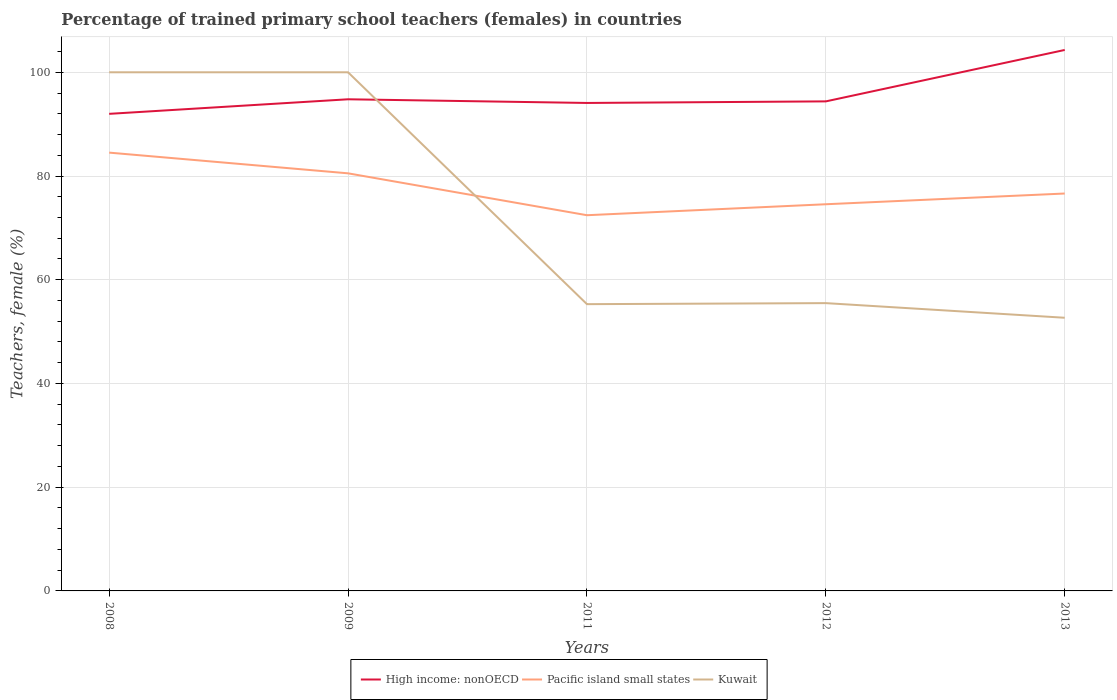How many different coloured lines are there?
Your answer should be very brief. 3. Does the line corresponding to Pacific island small states intersect with the line corresponding to Kuwait?
Give a very brief answer. Yes. Is the number of lines equal to the number of legend labels?
Keep it short and to the point. Yes. Across all years, what is the maximum percentage of trained primary school teachers (females) in Kuwait?
Keep it short and to the point. 52.67. In which year was the percentage of trained primary school teachers (females) in High income: nonOECD maximum?
Provide a short and direct response. 2008. What is the total percentage of trained primary school teachers (females) in Kuwait in the graph?
Make the answer very short. 44.51. What is the difference between the highest and the second highest percentage of trained primary school teachers (females) in High income: nonOECD?
Make the answer very short. 12.32. What is the difference between the highest and the lowest percentage of trained primary school teachers (females) in Kuwait?
Offer a very short reply. 2. How many lines are there?
Your response must be concise. 3. How many years are there in the graph?
Offer a terse response. 5. What is the difference between two consecutive major ticks on the Y-axis?
Offer a very short reply. 20. Are the values on the major ticks of Y-axis written in scientific E-notation?
Make the answer very short. No. Does the graph contain any zero values?
Give a very brief answer. No. Where does the legend appear in the graph?
Your answer should be very brief. Bottom center. How many legend labels are there?
Keep it short and to the point. 3. What is the title of the graph?
Your answer should be compact. Percentage of trained primary school teachers (females) in countries. What is the label or title of the X-axis?
Give a very brief answer. Years. What is the label or title of the Y-axis?
Offer a very short reply. Teachers, female (%). What is the Teachers, female (%) of High income: nonOECD in 2008?
Offer a very short reply. 91.99. What is the Teachers, female (%) in Pacific island small states in 2008?
Give a very brief answer. 84.51. What is the Teachers, female (%) of Kuwait in 2008?
Give a very brief answer. 100. What is the Teachers, female (%) in High income: nonOECD in 2009?
Your response must be concise. 94.79. What is the Teachers, female (%) in Pacific island small states in 2009?
Offer a terse response. 80.52. What is the Teachers, female (%) in Kuwait in 2009?
Your answer should be compact. 100. What is the Teachers, female (%) of High income: nonOECD in 2011?
Provide a short and direct response. 94.08. What is the Teachers, female (%) in Pacific island small states in 2011?
Your answer should be compact. 72.44. What is the Teachers, female (%) of Kuwait in 2011?
Give a very brief answer. 55.29. What is the Teachers, female (%) in High income: nonOECD in 2012?
Provide a short and direct response. 94.39. What is the Teachers, female (%) in Pacific island small states in 2012?
Make the answer very short. 74.55. What is the Teachers, female (%) of Kuwait in 2012?
Give a very brief answer. 55.49. What is the Teachers, female (%) in High income: nonOECD in 2013?
Provide a succinct answer. 104.3. What is the Teachers, female (%) in Pacific island small states in 2013?
Offer a very short reply. 76.62. What is the Teachers, female (%) of Kuwait in 2013?
Provide a short and direct response. 52.67. Across all years, what is the maximum Teachers, female (%) in High income: nonOECD?
Your answer should be compact. 104.3. Across all years, what is the maximum Teachers, female (%) of Pacific island small states?
Offer a very short reply. 84.51. Across all years, what is the maximum Teachers, female (%) of Kuwait?
Ensure brevity in your answer.  100. Across all years, what is the minimum Teachers, female (%) in High income: nonOECD?
Your answer should be very brief. 91.99. Across all years, what is the minimum Teachers, female (%) in Pacific island small states?
Your answer should be compact. 72.44. Across all years, what is the minimum Teachers, female (%) in Kuwait?
Your answer should be very brief. 52.67. What is the total Teachers, female (%) in High income: nonOECD in the graph?
Provide a succinct answer. 479.55. What is the total Teachers, female (%) of Pacific island small states in the graph?
Keep it short and to the point. 388.64. What is the total Teachers, female (%) in Kuwait in the graph?
Your answer should be compact. 363.45. What is the difference between the Teachers, female (%) in High income: nonOECD in 2008 and that in 2009?
Your response must be concise. -2.81. What is the difference between the Teachers, female (%) of Pacific island small states in 2008 and that in 2009?
Your answer should be very brief. 3.99. What is the difference between the Teachers, female (%) in Kuwait in 2008 and that in 2009?
Give a very brief answer. 0. What is the difference between the Teachers, female (%) of High income: nonOECD in 2008 and that in 2011?
Ensure brevity in your answer.  -2.1. What is the difference between the Teachers, female (%) in Pacific island small states in 2008 and that in 2011?
Your response must be concise. 12.07. What is the difference between the Teachers, female (%) in Kuwait in 2008 and that in 2011?
Keep it short and to the point. 44.71. What is the difference between the Teachers, female (%) of High income: nonOECD in 2008 and that in 2012?
Offer a very short reply. -2.4. What is the difference between the Teachers, female (%) of Pacific island small states in 2008 and that in 2012?
Your answer should be compact. 9.95. What is the difference between the Teachers, female (%) in Kuwait in 2008 and that in 2012?
Provide a short and direct response. 44.51. What is the difference between the Teachers, female (%) of High income: nonOECD in 2008 and that in 2013?
Offer a very short reply. -12.32. What is the difference between the Teachers, female (%) of Pacific island small states in 2008 and that in 2013?
Offer a terse response. 7.88. What is the difference between the Teachers, female (%) in Kuwait in 2008 and that in 2013?
Offer a very short reply. 47.33. What is the difference between the Teachers, female (%) in High income: nonOECD in 2009 and that in 2011?
Your answer should be compact. 0.71. What is the difference between the Teachers, female (%) of Pacific island small states in 2009 and that in 2011?
Give a very brief answer. 8.08. What is the difference between the Teachers, female (%) of Kuwait in 2009 and that in 2011?
Provide a short and direct response. 44.71. What is the difference between the Teachers, female (%) in High income: nonOECD in 2009 and that in 2012?
Give a very brief answer. 0.41. What is the difference between the Teachers, female (%) of Pacific island small states in 2009 and that in 2012?
Give a very brief answer. 5.96. What is the difference between the Teachers, female (%) of Kuwait in 2009 and that in 2012?
Your answer should be very brief. 44.51. What is the difference between the Teachers, female (%) of High income: nonOECD in 2009 and that in 2013?
Make the answer very short. -9.51. What is the difference between the Teachers, female (%) of Pacific island small states in 2009 and that in 2013?
Your answer should be compact. 3.89. What is the difference between the Teachers, female (%) of Kuwait in 2009 and that in 2013?
Your response must be concise. 47.33. What is the difference between the Teachers, female (%) in High income: nonOECD in 2011 and that in 2012?
Your answer should be very brief. -0.3. What is the difference between the Teachers, female (%) of Pacific island small states in 2011 and that in 2012?
Ensure brevity in your answer.  -2.12. What is the difference between the Teachers, female (%) in Kuwait in 2011 and that in 2012?
Keep it short and to the point. -0.2. What is the difference between the Teachers, female (%) of High income: nonOECD in 2011 and that in 2013?
Offer a terse response. -10.22. What is the difference between the Teachers, female (%) of Pacific island small states in 2011 and that in 2013?
Provide a short and direct response. -4.18. What is the difference between the Teachers, female (%) of Kuwait in 2011 and that in 2013?
Offer a very short reply. 2.62. What is the difference between the Teachers, female (%) of High income: nonOECD in 2012 and that in 2013?
Ensure brevity in your answer.  -9.91. What is the difference between the Teachers, female (%) in Pacific island small states in 2012 and that in 2013?
Make the answer very short. -2.07. What is the difference between the Teachers, female (%) of Kuwait in 2012 and that in 2013?
Keep it short and to the point. 2.82. What is the difference between the Teachers, female (%) of High income: nonOECD in 2008 and the Teachers, female (%) of Pacific island small states in 2009?
Your answer should be compact. 11.47. What is the difference between the Teachers, female (%) of High income: nonOECD in 2008 and the Teachers, female (%) of Kuwait in 2009?
Keep it short and to the point. -8.01. What is the difference between the Teachers, female (%) in Pacific island small states in 2008 and the Teachers, female (%) in Kuwait in 2009?
Provide a succinct answer. -15.49. What is the difference between the Teachers, female (%) of High income: nonOECD in 2008 and the Teachers, female (%) of Pacific island small states in 2011?
Your response must be concise. 19.55. What is the difference between the Teachers, female (%) in High income: nonOECD in 2008 and the Teachers, female (%) in Kuwait in 2011?
Provide a short and direct response. 36.69. What is the difference between the Teachers, female (%) in Pacific island small states in 2008 and the Teachers, female (%) in Kuwait in 2011?
Your answer should be compact. 29.22. What is the difference between the Teachers, female (%) in High income: nonOECD in 2008 and the Teachers, female (%) in Pacific island small states in 2012?
Your answer should be compact. 17.43. What is the difference between the Teachers, female (%) of High income: nonOECD in 2008 and the Teachers, female (%) of Kuwait in 2012?
Your answer should be very brief. 36.5. What is the difference between the Teachers, female (%) of Pacific island small states in 2008 and the Teachers, female (%) of Kuwait in 2012?
Provide a short and direct response. 29.02. What is the difference between the Teachers, female (%) in High income: nonOECD in 2008 and the Teachers, female (%) in Pacific island small states in 2013?
Your answer should be very brief. 15.36. What is the difference between the Teachers, female (%) in High income: nonOECD in 2008 and the Teachers, female (%) in Kuwait in 2013?
Your answer should be very brief. 39.32. What is the difference between the Teachers, female (%) in Pacific island small states in 2008 and the Teachers, female (%) in Kuwait in 2013?
Your response must be concise. 31.84. What is the difference between the Teachers, female (%) in High income: nonOECD in 2009 and the Teachers, female (%) in Pacific island small states in 2011?
Provide a succinct answer. 22.36. What is the difference between the Teachers, female (%) of High income: nonOECD in 2009 and the Teachers, female (%) of Kuwait in 2011?
Provide a succinct answer. 39.5. What is the difference between the Teachers, female (%) in Pacific island small states in 2009 and the Teachers, female (%) in Kuwait in 2011?
Keep it short and to the point. 25.23. What is the difference between the Teachers, female (%) in High income: nonOECD in 2009 and the Teachers, female (%) in Pacific island small states in 2012?
Offer a very short reply. 20.24. What is the difference between the Teachers, female (%) of High income: nonOECD in 2009 and the Teachers, female (%) of Kuwait in 2012?
Give a very brief answer. 39.31. What is the difference between the Teachers, female (%) in Pacific island small states in 2009 and the Teachers, female (%) in Kuwait in 2012?
Your response must be concise. 25.03. What is the difference between the Teachers, female (%) in High income: nonOECD in 2009 and the Teachers, female (%) in Pacific island small states in 2013?
Provide a short and direct response. 18.17. What is the difference between the Teachers, female (%) of High income: nonOECD in 2009 and the Teachers, female (%) of Kuwait in 2013?
Your response must be concise. 42.13. What is the difference between the Teachers, female (%) in Pacific island small states in 2009 and the Teachers, female (%) in Kuwait in 2013?
Ensure brevity in your answer.  27.85. What is the difference between the Teachers, female (%) of High income: nonOECD in 2011 and the Teachers, female (%) of Pacific island small states in 2012?
Offer a terse response. 19.53. What is the difference between the Teachers, female (%) of High income: nonOECD in 2011 and the Teachers, female (%) of Kuwait in 2012?
Offer a terse response. 38.6. What is the difference between the Teachers, female (%) of Pacific island small states in 2011 and the Teachers, female (%) of Kuwait in 2012?
Your response must be concise. 16.95. What is the difference between the Teachers, female (%) of High income: nonOECD in 2011 and the Teachers, female (%) of Pacific island small states in 2013?
Your answer should be very brief. 17.46. What is the difference between the Teachers, female (%) of High income: nonOECD in 2011 and the Teachers, female (%) of Kuwait in 2013?
Provide a succinct answer. 41.42. What is the difference between the Teachers, female (%) of Pacific island small states in 2011 and the Teachers, female (%) of Kuwait in 2013?
Offer a terse response. 19.77. What is the difference between the Teachers, female (%) in High income: nonOECD in 2012 and the Teachers, female (%) in Pacific island small states in 2013?
Make the answer very short. 17.76. What is the difference between the Teachers, female (%) in High income: nonOECD in 2012 and the Teachers, female (%) in Kuwait in 2013?
Provide a short and direct response. 41.72. What is the difference between the Teachers, female (%) in Pacific island small states in 2012 and the Teachers, female (%) in Kuwait in 2013?
Your answer should be very brief. 21.89. What is the average Teachers, female (%) in High income: nonOECD per year?
Make the answer very short. 95.91. What is the average Teachers, female (%) in Pacific island small states per year?
Give a very brief answer. 77.73. What is the average Teachers, female (%) of Kuwait per year?
Make the answer very short. 72.69. In the year 2008, what is the difference between the Teachers, female (%) of High income: nonOECD and Teachers, female (%) of Pacific island small states?
Your answer should be very brief. 7.48. In the year 2008, what is the difference between the Teachers, female (%) in High income: nonOECD and Teachers, female (%) in Kuwait?
Offer a terse response. -8.01. In the year 2008, what is the difference between the Teachers, female (%) in Pacific island small states and Teachers, female (%) in Kuwait?
Your answer should be compact. -15.49. In the year 2009, what is the difference between the Teachers, female (%) of High income: nonOECD and Teachers, female (%) of Pacific island small states?
Give a very brief answer. 14.28. In the year 2009, what is the difference between the Teachers, female (%) of High income: nonOECD and Teachers, female (%) of Kuwait?
Provide a short and direct response. -5.21. In the year 2009, what is the difference between the Teachers, female (%) of Pacific island small states and Teachers, female (%) of Kuwait?
Your response must be concise. -19.48. In the year 2011, what is the difference between the Teachers, female (%) of High income: nonOECD and Teachers, female (%) of Pacific island small states?
Your answer should be very brief. 21.65. In the year 2011, what is the difference between the Teachers, female (%) in High income: nonOECD and Teachers, female (%) in Kuwait?
Offer a terse response. 38.79. In the year 2011, what is the difference between the Teachers, female (%) of Pacific island small states and Teachers, female (%) of Kuwait?
Make the answer very short. 17.15. In the year 2012, what is the difference between the Teachers, female (%) in High income: nonOECD and Teachers, female (%) in Pacific island small states?
Ensure brevity in your answer.  19.83. In the year 2012, what is the difference between the Teachers, female (%) in High income: nonOECD and Teachers, female (%) in Kuwait?
Ensure brevity in your answer.  38.9. In the year 2012, what is the difference between the Teachers, female (%) of Pacific island small states and Teachers, female (%) of Kuwait?
Make the answer very short. 19.07. In the year 2013, what is the difference between the Teachers, female (%) in High income: nonOECD and Teachers, female (%) in Pacific island small states?
Provide a short and direct response. 27.68. In the year 2013, what is the difference between the Teachers, female (%) in High income: nonOECD and Teachers, female (%) in Kuwait?
Provide a succinct answer. 51.63. In the year 2013, what is the difference between the Teachers, female (%) of Pacific island small states and Teachers, female (%) of Kuwait?
Provide a succinct answer. 23.96. What is the ratio of the Teachers, female (%) of High income: nonOECD in 2008 to that in 2009?
Your answer should be very brief. 0.97. What is the ratio of the Teachers, female (%) of Pacific island small states in 2008 to that in 2009?
Provide a succinct answer. 1.05. What is the ratio of the Teachers, female (%) in Kuwait in 2008 to that in 2009?
Your answer should be very brief. 1. What is the ratio of the Teachers, female (%) in High income: nonOECD in 2008 to that in 2011?
Offer a terse response. 0.98. What is the ratio of the Teachers, female (%) in Pacific island small states in 2008 to that in 2011?
Offer a very short reply. 1.17. What is the ratio of the Teachers, female (%) in Kuwait in 2008 to that in 2011?
Your answer should be very brief. 1.81. What is the ratio of the Teachers, female (%) in High income: nonOECD in 2008 to that in 2012?
Your response must be concise. 0.97. What is the ratio of the Teachers, female (%) in Pacific island small states in 2008 to that in 2012?
Make the answer very short. 1.13. What is the ratio of the Teachers, female (%) in Kuwait in 2008 to that in 2012?
Offer a terse response. 1.8. What is the ratio of the Teachers, female (%) of High income: nonOECD in 2008 to that in 2013?
Your response must be concise. 0.88. What is the ratio of the Teachers, female (%) in Pacific island small states in 2008 to that in 2013?
Give a very brief answer. 1.1. What is the ratio of the Teachers, female (%) of Kuwait in 2008 to that in 2013?
Offer a terse response. 1.9. What is the ratio of the Teachers, female (%) of High income: nonOECD in 2009 to that in 2011?
Ensure brevity in your answer.  1.01. What is the ratio of the Teachers, female (%) in Pacific island small states in 2009 to that in 2011?
Keep it short and to the point. 1.11. What is the ratio of the Teachers, female (%) of Kuwait in 2009 to that in 2011?
Provide a succinct answer. 1.81. What is the ratio of the Teachers, female (%) of Pacific island small states in 2009 to that in 2012?
Your answer should be compact. 1.08. What is the ratio of the Teachers, female (%) in Kuwait in 2009 to that in 2012?
Offer a terse response. 1.8. What is the ratio of the Teachers, female (%) of High income: nonOECD in 2009 to that in 2013?
Offer a terse response. 0.91. What is the ratio of the Teachers, female (%) of Pacific island small states in 2009 to that in 2013?
Your answer should be compact. 1.05. What is the ratio of the Teachers, female (%) in Kuwait in 2009 to that in 2013?
Offer a terse response. 1.9. What is the ratio of the Teachers, female (%) of Pacific island small states in 2011 to that in 2012?
Provide a short and direct response. 0.97. What is the ratio of the Teachers, female (%) of Kuwait in 2011 to that in 2012?
Make the answer very short. 1. What is the ratio of the Teachers, female (%) of High income: nonOECD in 2011 to that in 2013?
Offer a terse response. 0.9. What is the ratio of the Teachers, female (%) in Pacific island small states in 2011 to that in 2013?
Your response must be concise. 0.95. What is the ratio of the Teachers, female (%) in Kuwait in 2011 to that in 2013?
Make the answer very short. 1.05. What is the ratio of the Teachers, female (%) in High income: nonOECD in 2012 to that in 2013?
Keep it short and to the point. 0.91. What is the ratio of the Teachers, female (%) of Kuwait in 2012 to that in 2013?
Offer a terse response. 1.05. What is the difference between the highest and the second highest Teachers, female (%) of High income: nonOECD?
Keep it short and to the point. 9.51. What is the difference between the highest and the second highest Teachers, female (%) of Pacific island small states?
Ensure brevity in your answer.  3.99. What is the difference between the highest and the second highest Teachers, female (%) in Kuwait?
Your answer should be compact. 0. What is the difference between the highest and the lowest Teachers, female (%) of High income: nonOECD?
Ensure brevity in your answer.  12.32. What is the difference between the highest and the lowest Teachers, female (%) of Pacific island small states?
Provide a succinct answer. 12.07. What is the difference between the highest and the lowest Teachers, female (%) of Kuwait?
Ensure brevity in your answer.  47.33. 